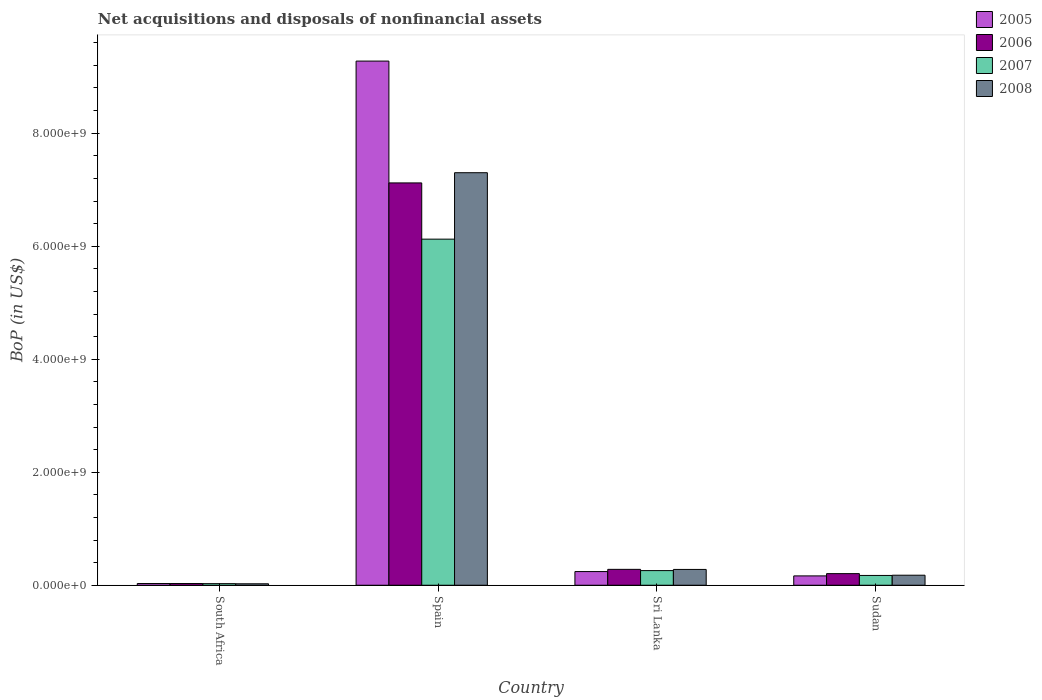Are the number of bars per tick equal to the number of legend labels?
Your response must be concise. Yes. How many bars are there on the 3rd tick from the left?
Offer a very short reply. 4. What is the Balance of Payments in 2008 in South Africa?
Provide a succinct answer. 2.55e+07. Across all countries, what is the maximum Balance of Payments in 2005?
Ensure brevity in your answer.  9.28e+09. Across all countries, what is the minimum Balance of Payments in 2008?
Offer a terse response. 2.55e+07. In which country was the Balance of Payments in 2005 minimum?
Provide a short and direct response. South Africa. What is the total Balance of Payments in 2005 in the graph?
Provide a succinct answer. 9.71e+09. What is the difference between the Balance of Payments in 2007 in Spain and that in Sri Lanka?
Ensure brevity in your answer.  5.87e+09. What is the difference between the Balance of Payments in 2006 in South Africa and the Balance of Payments in 2007 in Spain?
Provide a succinct answer. -6.09e+09. What is the average Balance of Payments in 2007 per country?
Offer a terse response. 1.65e+09. What is the difference between the Balance of Payments of/in 2005 and Balance of Payments of/in 2006 in Sudan?
Give a very brief answer. -4.00e+07. What is the ratio of the Balance of Payments in 2008 in Spain to that in Sudan?
Your answer should be very brief. 41.14. Is the Balance of Payments in 2008 in Spain less than that in Sri Lanka?
Provide a succinct answer. No. Is the difference between the Balance of Payments in 2005 in Spain and Sudan greater than the difference between the Balance of Payments in 2006 in Spain and Sudan?
Make the answer very short. Yes. What is the difference between the highest and the second highest Balance of Payments in 2007?
Provide a short and direct response. 8.58e+07. What is the difference between the highest and the lowest Balance of Payments in 2008?
Ensure brevity in your answer.  7.28e+09. Is the sum of the Balance of Payments in 2005 in Spain and Sri Lanka greater than the maximum Balance of Payments in 2008 across all countries?
Offer a terse response. Yes. Is it the case that in every country, the sum of the Balance of Payments in 2007 and Balance of Payments in 2006 is greater than the sum of Balance of Payments in 2005 and Balance of Payments in 2008?
Provide a succinct answer. No. Is it the case that in every country, the sum of the Balance of Payments in 2006 and Balance of Payments in 2008 is greater than the Balance of Payments in 2005?
Your answer should be very brief. Yes. How many countries are there in the graph?
Keep it short and to the point. 4. Does the graph contain grids?
Give a very brief answer. No. How many legend labels are there?
Provide a short and direct response. 4. How are the legend labels stacked?
Give a very brief answer. Vertical. What is the title of the graph?
Give a very brief answer. Net acquisitions and disposals of nonfinancial assets. What is the label or title of the X-axis?
Keep it short and to the point. Country. What is the label or title of the Y-axis?
Ensure brevity in your answer.  BoP (in US$). What is the BoP (in US$) of 2005 in South Africa?
Your answer should be very brief. 3.04e+07. What is the BoP (in US$) of 2006 in South Africa?
Your answer should be compact. 3.02e+07. What is the BoP (in US$) in 2007 in South Africa?
Provide a short and direct response. 2.80e+07. What is the BoP (in US$) in 2008 in South Africa?
Offer a terse response. 2.55e+07. What is the BoP (in US$) in 2005 in Spain?
Provide a succinct answer. 9.28e+09. What is the BoP (in US$) in 2006 in Spain?
Offer a terse response. 7.12e+09. What is the BoP (in US$) of 2007 in Spain?
Offer a very short reply. 6.12e+09. What is the BoP (in US$) of 2008 in Spain?
Give a very brief answer. 7.30e+09. What is the BoP (in US$) of 2005 in Sri Lanka?
Provide a short and direct response. 2.42e+08. What is the BoP (in US$) of 2006 in Sri Lanka?
Give a very brief answer. 2.81e+08. What is the BoP (in US$) of 2007 in Sri Lanka?
Provide a succinct answer. 2.59e+08. What is the BoP (in US$) in 2008 in Sri Lanka?
Your answer should be compact. 2.80e+08. What is the BoP (in US$) of 2005 in Sudan?
Make the answer very short. 1.65e+08. What is the BoP (in US$) of 2006 in Sudan?
Your answer should be compact. 2.05e+08. What is the BoP (in US$) in 2007 in Sudan?
Ensure brevity in your answer.  1.73e+08. What is the BoP (in US$) of 2008 in Sudan?
Provide a short and direct response. 1.77e+08. Across all countries, what is the maximum BoP (in US$) of 2005?
Offer a very short reply. 9.28e+09. Across all countries, what is the maximum BoP (in US$) in 2006?
Your answer should be compact. 7.12e+09. Across all countries, what is the maximum BoP (in US$) of 2007?
Make the answer very short. 6.12e+09. Across all countries, what is the maximum BoP (in US$) of 2008?
Provide a short and direct response. 7.30e+09. Across all countries, what is the minimum BoP (in US$) in 2005?
Give a very brief answer. 3.04e+07. Across all countries, what is the minimum BoP (in US$) in 2006?
Your answer should be very brief. 3.02e+07. Across all countries, what is the minimum BoP (in US$) in 2007?
Give a very brief answer. 2.80e+07. Across all countries, what is the minimum BoP (in US$) in 2008?
Your response must be concise. 2.55e+07. What is the total BoP (in US$) of 2005 in the graph?
Provide a succinct answer. 9.71e+09. What is the total BoP (in US$) of 2006 in the graph?
Your response must be concise. 7.64e+09. What is the total BoP (in US$) in 2007 in the graph?
Your answer should be very brief. 6.59e+09. What is the total BoP (in US$) of 2008 in the graph?
Give a very brief answer. 7.78e+09. What is the difference between the BoP (in US$) in 2005 in South Africa and that in Spain?
Your answer should be compact. -9.25e+09. What is the difference between the BoP (in US$) in 2006 in South Africa and that in Spain?
Keep it short and to the point. -7.09e+09. What is the difference between the BoP (in US$) of 2007 in South Africa and that in Spain?
Provide a succinct answer. -6.10e+09. What is the difference between the BoP (in US$) in 2008 in South Africa and that in Spain?
Keep it short and to the point. -7.28e+09. What is the difference between the BoP (in US$) of 2005 in South Africa and that in Sri Lanka?
Provide a short and direct response. -2.12e+08. What is the difference between the BoP (in US$) in 2006 in South Africa and that in Sri Lanka?
Ensure brevity in your answer.  -2.51e+08. What is the difference between the BoP (in US$) of 2007 in South Africa and that in Sri Lanka?
Provide a short and direct response. -2.31e+08. What is the difference between the BoP (in US$) in 2008 in South Africa and that in Sri Lanka?
Make the answer very short. -2.54e+08. What is the difference between the BoP (in US$) of 2005 in South Africa and that in Sudan?
Offer a very short reply. -1.35e+08. What is the difference between the BoP (in US$) of 2006 in South Africa and that in Sudan?
Provide a succinct answer. -1.75e+08. What is the difference between the BoP (in US$) of 2007 in South Africa and that in Sudan?
Provide a succinct answer. -1.45e+08. What is the difference between the BoP (in US$) of 2008 in South Africa and that in Sudan?
Make the answer very short. -1.52e+08. What is the difference between the BoP (in US$) in 2005 in Spain and that in Sri Lanka?
Make the answer very short. 9.03e+09. What is the difference between the BoP (in US$) in 2006 in Spain and that in Sri Lanka?
Offer a terse response. 6.84e+09. What is the difference between the BoP (in US$) of 2007 in Spain and that in Sri Lanka?
Your response must be concise. 5.87e+09. What is the difference between the BoP (in US$) in 2008 in Spain and that in Sri Lanka?
Ensure brevity in your answer.  7.02e+09. What is the difference between the BoP (in US$) in 2005 in Spain and that in Sudan?
Provide a succinct answer. 9.11e+09. What is the difference between the BoP (in US$) of 2006 in Spain and that in Sudan?
Your response must be concise. 6.91e+09. What is the difference between the BoP (in US$) in 2007 in Spain and that in Sudan?
Offer a terse response. 5.95e+09. What is the difference between the BoP (in US$) of 2008 in Spain and that in Sudan?
Your answer should be very brief. 7.12e+09. What is the difference between the BoP (in US$) in 2005 in Sri Lanka and that in Sudan?
Your response must be concise. 7.67e+07. What is the difference between the BoP (in US$) of 2006 in Sri Lanka and that in Sudan?
Offer a terse response. 7.58e+07. What is the difference between the BoP (in US$) of 2007 in Sri Lanka and that in Sudan?
Offer a very short reply. 8.58e+07. What is the difference between the BoP (in US$) of 2008 in Sri Lanka and that in Sudan?
Provide a short and direct response. 1.02e+08. What is the difference between the BoP (in US$) in 2005 in South Africa and the BoP (in US$) in 2006 in Spain?
Your response must be concise. -7.09e+09. What is the difference between the BoP (in US$) in 2005 in South Africa and the BoP (in US$) in 2007 in Spain?
Your response must be concise. -6.09e+09. What is the difference between the BoP (in US$) of 2005 in South Africa and the BoP (in US$) of 2008 in Spain?
Ensure brevity in your answer.  -7.27e+09. What is the difference between the BoP (in US$) of 2006 in South Africa and the BoP (in US$) of 2007 in Spain?
Keep it short and to the point. -6.09e+09. What is the difference between the BoP (in US$) in 2006 in South Africa and the BoP (in US$) in 2008 in Spain?
Offer a very short reply. -7.27e+09. What is the difference between the BoP (in US$) in 2007 in South Africa and the BoP (in US$) in 2008 in Spain?
Your answer should be compact. -7.27e+09. What is the difference between the BoP (in US$) of 2005 in South Africa and the BoP (in US$) of 2006 in Sri Lanka?
Ensure brevity in your answer.  -2.51e+08. What is the difference between the BoP (in US$) in 2005 in South Africa and the BoP (in US$) in 2007 in Sri Lanka?
Ensure brevity in your answer.  -2.29e+08. What is the difference between the BoP (in US$) in 2005 in South Africa and the BoP (in US$) in 2008 in Sri Lanka?
Offer a very short reply. -2.49e+08. What is the difference between the BoP (in US$) of 2006 in South Africa and the BoP (in US$) of 2007 in Sri Lanka?
Provide a succinct answer. -2.29e+08. What is the difference between the BoP (in US$) of 2006 in South Africa and the BoP (in US$) of 2008 in Sri Lanka?
Offer a very short reply. -2.49e+08. What is the difference between the BoP (in US$) of 2007 in South Africa and the BoP (in US$) of 2008 in Sri Lanka?
Ensure brevity in your answer.  -2.52e+08. What is the difference between the BoP (in US$) of 2005 in South Africa and the BoP (in US$) of 2006 in Sudan?
Keep it short and to the point. -1.75e+08. What is the difference between the BoP (in US$) in 2005 in South Africa and the BoP (in US$) in 2007 in Sudan?
Give a very brief answer. -1.43e+08. What is the difference between the BoP (in US$) in 2005 in South Africa and the BoP (in US$) in 2008 in Sudan?
Provide a succinct answer. -1.47e+08. What is the difference between the BoP (in US$) of 2006 in South Africa and the BoP (in US$) of 2007 in Sudan?
Your response must be concise. -1.43e+08. What is the difference between the BoP (in US$) of 2006 in South Africa and the BoP (in US$) of 2008 in Sudan?
Provide a short and direct response. -1.47e+08. What is the difference between the BoP (in US$) in 2007 in South Africa and the BoP (in US$) in 2008 in Sudan?
Offer a terse response. -1.49e+08. What is the difference between the BoP (in US$) of 2005 in Spain and the BoP (in US$) of 2006 in Sri Lanka?
Keep it short and to the point. 9.00e+09. What is the difference between the BoP (in US$) of 2005 in Spain and the BoP (in US$) of 2007 in Sri Lanka?
Your answer should be very brief. 9.02e+09. What is the difference between the BoP (in US$) of 2005 in Spain and the BoP (in US$) of 2008 in Sri Lanka?
Your answer should be compact. 9.00e+09. What is the difference between the BoP (in US$) of 2006 in Spain and the BoP (in US$) of 2007 in Sri Lanka?
Offer a terse response. 6.86e+09. What is the difference between the BoP (in US$) of 2006 in Spain and the BoP (in US$) of 2008 in Sri Lanka?
Your answer should be compact. 6.84e+09. What is the difference between the BoP (in US$) of 2007 in Spain and the BoP (in US$) of 2008 in Sri Lanka?
Ensure brevity in your answer.  5.85e+09. What is the difference between the BoP (in US$) in 2005 in Spain and the BoP (in US$) in 2006 in Sudan?
Give a very brief answer. 9.07e+09. What is the difference between the BoP (in US$) of 2005 in Spain and the BoP (in US$) of 2007 in Sudan?
Offer a very short reply. 9.10e+09. What is the difference between the BoP (in US$) of 2005 in Spain and the BoP (in US$) of 2008 in Sudan?
Provide a succinct answer. 9.10e+09. What is the difference between the BoP (in US$) of 2006 in Spain and the BoP (in US$) of 2007 in Sudan?
Keep it short and to the point. 6.95e+09. What is the difference between the BoP (in US$) in 2006 in Spain and the BoP (in US$) in 2008 in Sudan?
Your answer should be compact. 6.94e+09. What is the difference between the BoP (in US$) in 2007 in Spain and the BoP (in US$) in 2008 in Sudan?
Provide a short and direct response. 5.95e+09. What is the difference between the BoP (in US$) in 2005 in Sri Lanka and the BoP (in US$) in 2006 in Sudan?
Keep it short and to the point. 3.67e+07. What is the difference between the BoP (in US$) in 2005 in Sri Lanka and the BoP (in US$) in 2007 in Sudan?
Offer a very short reply. 6.88e+07. What is the difference between the BoP (in US$) of 2005 in Sri Lanka and the BoP (in US$) of 2008 in Sudan?
Provide a succinct answer. 6.45e+07. What is the difference between the BoP (in US$) of 2006 in Sri Lanka and the BoP (in US$) of 2007 in Sudan?
Provide a short and direct response. 1.08e+08. What is the difference between the BoP (in US$) in 2006 in Sri Lanka and the BoP (in US$) in 2008 in Sudan?
Your answer should be very brief. 1.04e+08. What is the difference between the BoP (in US$) in 2007 in Sri Lanka and the BoP (in US$) in 2008 in Sudan?
Make the answer very short. 8.16e+07. What is the average BoP (in US$) of 2005 per country?
Make the answer very short. 2.43e+09. What is the average BoP (in US$) in 2006 per country?
Your response must be concise. 1.91e+09. What is the average BoP (in US$) in 2007 per country?
Make the answer very short. 1.65e+09. What is the average BoP (in US$) in 2008 per country?
Provide a short and direct response. 1.95e+09. What is the difference between the BoP (in US$) of 2005 and BoP (in US$) of 2006 in South Africa?
Your answer should be very brief. 2.02e+05. What is the difference between the BoP (in US$) in 2005 and BoP (in US$) in 2007 in South Africa?
Offer a terse response. 2.47e+06. What is the difference between the BoP (in US$) in 2005 and BoP (in US$) in 2008 in South Africa?
Offer a very short reply. 4.95e+06. What is the difference between the BoP (in US$) in 2006 and BoP (in US$) in 2007 in South Africa?
Give a very brief answer. 2.26e+06. What is the difference between the BoP (in US$) in 2006 and BoP (in US$) in 2008 in South Africa?
Make the answer very short. 4.74e+06. What is the difference between the BoP (in US$) in 2007 and BoP (in US$) in 2008 in South Africa?
Your response must be concise. 2.48e+06. What is the difference between the BoP (in US$) of 2005 and BoP (in US$) of 2006 in Spain?
Your answer should be very brief. 2.16e+09. What is the difference between the BoP (in US$) in 2005 and BoP (in US$) in 2007 in Spain?
Your answer should be compact. 3.15e+09. What is the difference between the BoP (in US$) in 2005 and BoP (in US$) in 2008 in Spain?
Offer a very short reply. 1.98e+09. What is the difference between the BoP (in US$) of 2006 and BoP (in US$) of 2007 in Spain?
Give a very brief answer. 9.95e+08. What is the difference between the BoP (in US$) of 2006 and BoP (in US$) of 2008 in Spain?
Provide a succinct answer. -1.81e+08. What is the difference between the BoP (in US$) of 2007 and BoP (in US$) of 2008 in Spain?
Offer a very short reply. -1.18e+09. What is the difference between the BoP (in US$) in 2005 and BoP (in US$) in 2006 in Sri Lanka?
Provide a succinct answer. -3.91e+07. What is the difference between the BoP (in US$) in 2005 and BoP (in US$) in 2007 in Sri Lanka?
Offer a terse response. -1.70e+07. What is the difference between the BoP (in US$) in 2005 and BoP (in US$) in 2008 in Sri Lanka?
Your response must be concise. -3.77e+07. What is the difference between the BoP (in US$) of 2006 and BoP (in US$) of 2007 in Sri Lanka?
Your response must be concise. 2.20e+07. What is the difference between the BoP (in US$) in 2006 and BoP (in US$) in 2008 in Sri Lanka?
Offer a terse response. 1.40e+06. What is the difference between the BoP (in US$) of 2007 and BoP (in US$) of 2008 in Sri Lanka?
Make the answer very short. -2.06e+07. What is the difference between the BoP (in US$) in 2005 and BoP (in US$) in 2006 in Sudan?
Offer a very short reply. -4.00e+07. What is the difference between the BoP (in US$) of 2005 and BoP (in US$) of 2007 in Sudan?
Provide a succinct answer. -7.94e+06. What is the difference between the BoP (in US$) of 2005 and BoP (in US$) of 2008 in Sudan?
Provide a succinct answer. -1.22e+07. What is the difference between the BoP (in US$) of 2006 and BoP (in US$) of 2007 in Sudan?
Provide a succinct answer. 3.21e+07. What is the difference between the BoP (in US$) in 2006 and BoP (in US$) in 2008 in Sudan?
Provide a succinct answer. 2.78e+07. What is the difference between the BoP (in US$) of 2007 and BoP (in US$) of 2008 in Sudan?
Provide a short and direct response. -4.24e+06. What is the ratio of the BoP (in US$) in 2005 in South Africa to that in Spain?
Your answer should be compact. 0. What is the ratio of the BoP (in US$) of 2006 in South Africa to that in Spain?
Your answer should be very brief. 0. What is the ratio of the BoP (in US$) in 2007 in South Africa to that in Spain?
Keep it short and to the point. 0. What is the ratio of the BoP (in US$) in 2008 in South Africa to that in Spain?
Your answer should be very brief. 0. What is the ratio of the BoP (in US$) of 2005 in South Africa to that in Sri Lanka?
Provide a succinct answer. 0.13. What is the ratio of the BoP (in US$) of 2006 in South Africa to that in Sri Lanka?
Provide a short and direct response. 0.11. What is the ratio of the BoP (in US$) of 2007 in South Africa to that in Sri Lanka?
Keep it short and to the point. 0.11. What is the ratio of the BoP (in US$) of 2008 in South Africa to that in Sri Lanka?
Provide a succinct answer. 0.09. What is the ratio of the BoP (in US$) of 2005 in South Africa to that in Sudan?
Offer a very short reply. 0.18. What is the ratio of the BoP (in US$) of 2006 in South Africa to that in Sudan?
Provide a succinct answer. 0.15. What is the ratio of the BoP (in US$) in 2007 in South Africa to that in Sudan?
Give a very brief answer. 0.16. What is the ratio of the BoP (in US$) of 2008 in South Africa to that in Sudan?
Give a very brief answer. 0.14. What is the ratio of the BoP (in US$) of 2005 in Spain to that in Sri Lanka?
Give a very brief answer. 38.33. What is the ratio of the BoP (in US$) in 2006 in Spain to that in Sri Lanka?
Offer a very short reply. 25.33. What is the ratio of the BoP (in US$) in 2007 in Spain to that in Sri Lanka?
Give a very brief answer. 23.64. What is the ratio of the BoP (in US$) in 2008 in Spain to that in Sri Lanka?
Make the answer very short. 26.1. What is the ratio of the BoP (in US$) in 2005 in Spain to that in Sudan?
Your answer should be compact. 56.12. What is the ratio of the BoP (in US$) in 2006 in Spain to that in Sudan?
Provide a succinct answer. 34.68. What is the ratio of the BoP (in US$) in 2007 in Spain to that in Sudan?
Ensure brevity in your answer.  35.36. What is the ratio of the BoP (in US$) in 2008 in Spain to that in Sudan?
Provide a short and direct response. 41.14. What is the ratio of the BoP (in US$) of 2005 in Sri Lanka to that in Sudan?
Make the answer very short. 1.46. What is the ratio of the BoP (in US$) in 2006 in Sri Lanka to that in Sudan?
Keep it short and to the point. 1.37. What is the ratio of the BoP (in US$) in 2007 in Sri Lanka to that in Sudan?
Keep it short and to the point. 1.5. What is the ratio of the BoP (in US$) in 2008 in Sri Lanka to that in Sudan?
Give a very brief answer. 1.58. What is the difference between the highest and the second highest BoP (in US$) of 2005?
Offer a very short reply. 9.03e+09. What is the difference between the highest and the second highest BoP (in US$) in 2006?
Your answer should be compact. 6.84e+09. What is the difference between the highest and the second highest BoP (in US$) in 2007?
Make the answer very short. 5.87e+09. What is the difference between the highest and the second highest BoP (in US$) in 2008?
Keep it short and to the point. 7.02e+09. What is the difference between the highest and the lowest BoP (in US$) in 2005?
Provide a short and direct response. 9.25e+09. What is the difference between the highest and the lowest BoP (in US$) of 2006?
Provide a short and direct response. 7.09e+09. What is the difference between the highest and the lowest BoP (in US$) in 2007?
Offer a terse response. 6.10e+09. What is the difference between the highest and the lowest BoP (in US$) of 2008?
Offer a terse response. 7.28e+09. 